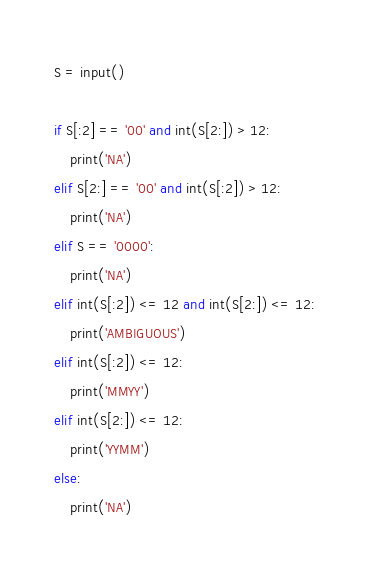Convert code to text. <code><loc_0><loc_0><loc_500><loc_500><_Python_>S = input()

if S[:2] == '00' and int(S[2:]) > 12:
    print('NA')
elif S[2:] == '00' and int(S[:2]) > 12:
    print('NA')
elif S == '0000':
    print('NA')
elif int(S[:2]) <= 12 and int(S[2:]) <= 12:
    print('AMBIGUOUS')
elif int(S[:2]) <= 12:
    print('MMYY')
elif int(S[2:]) <= 12:
    print('YYMM')
else:
    print('NA')</code> 